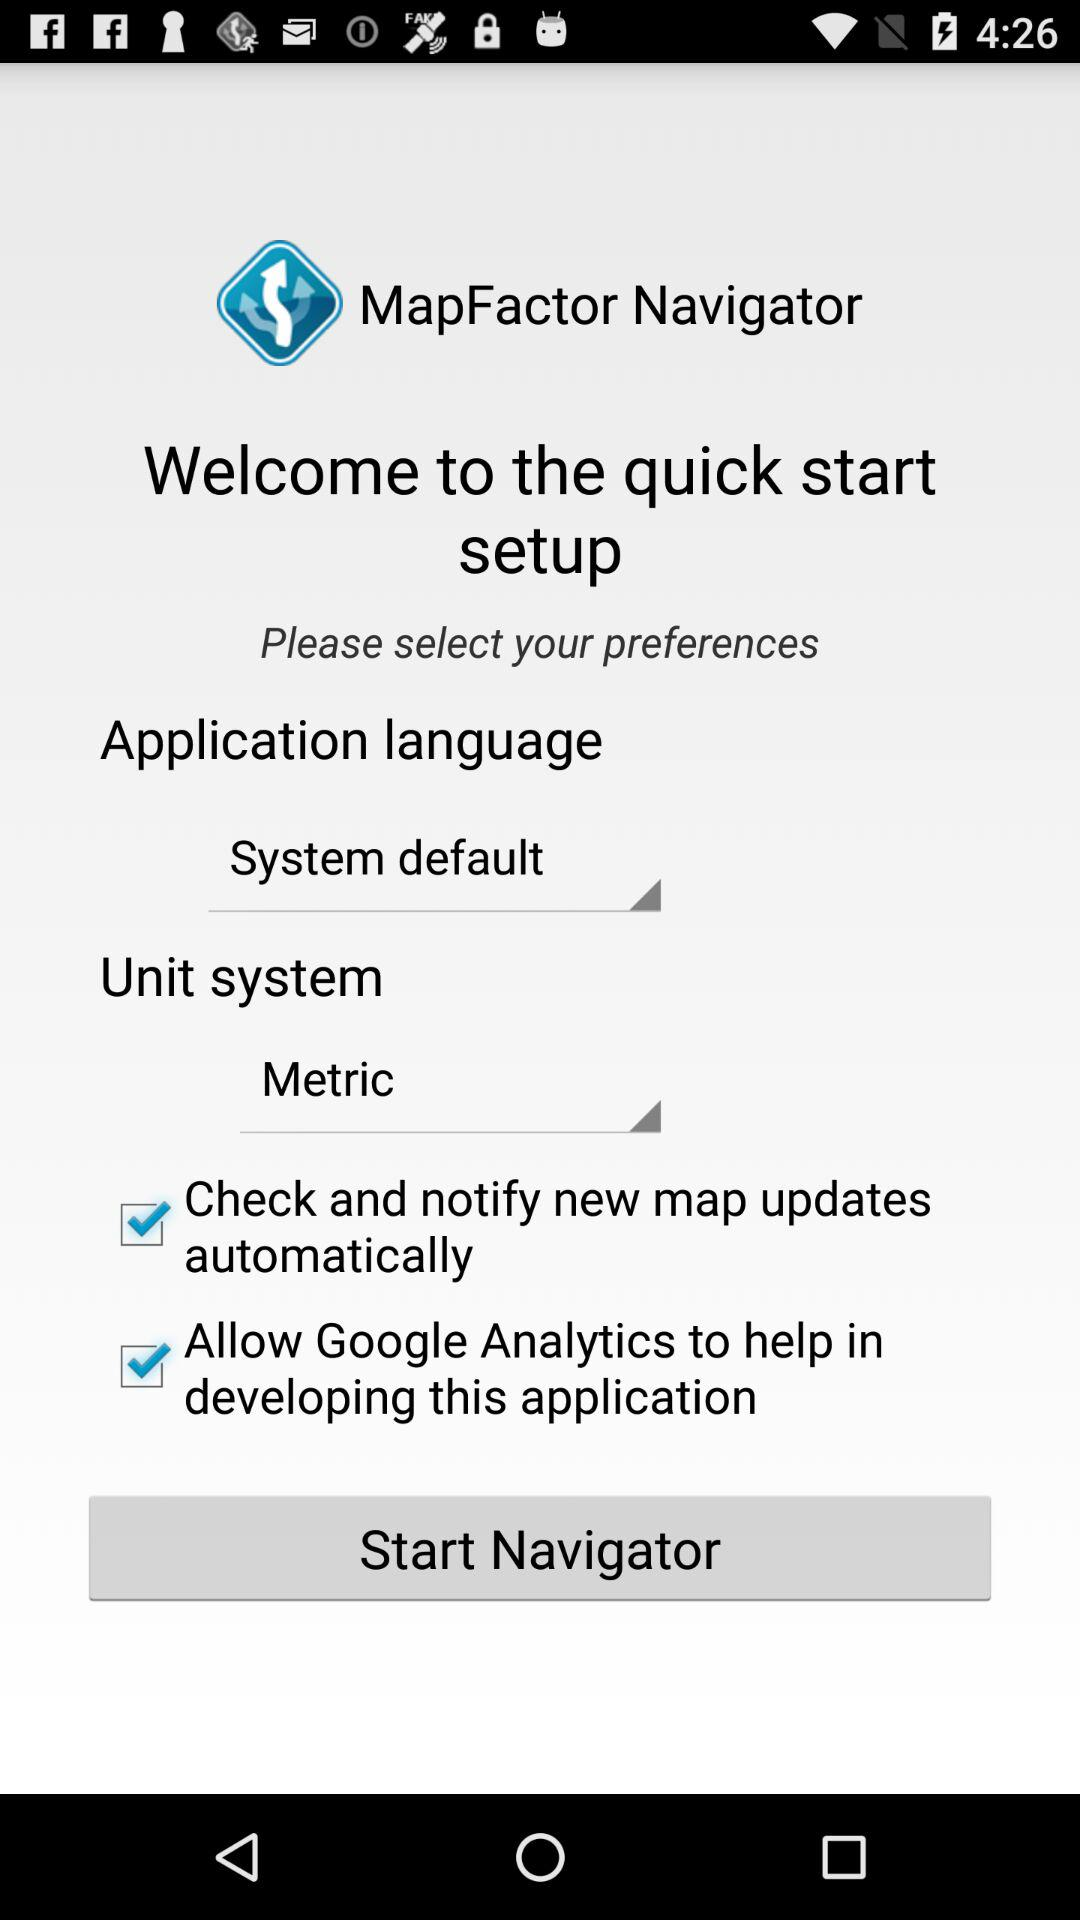What is the app name? The app name is "MapFactor Navigator". 